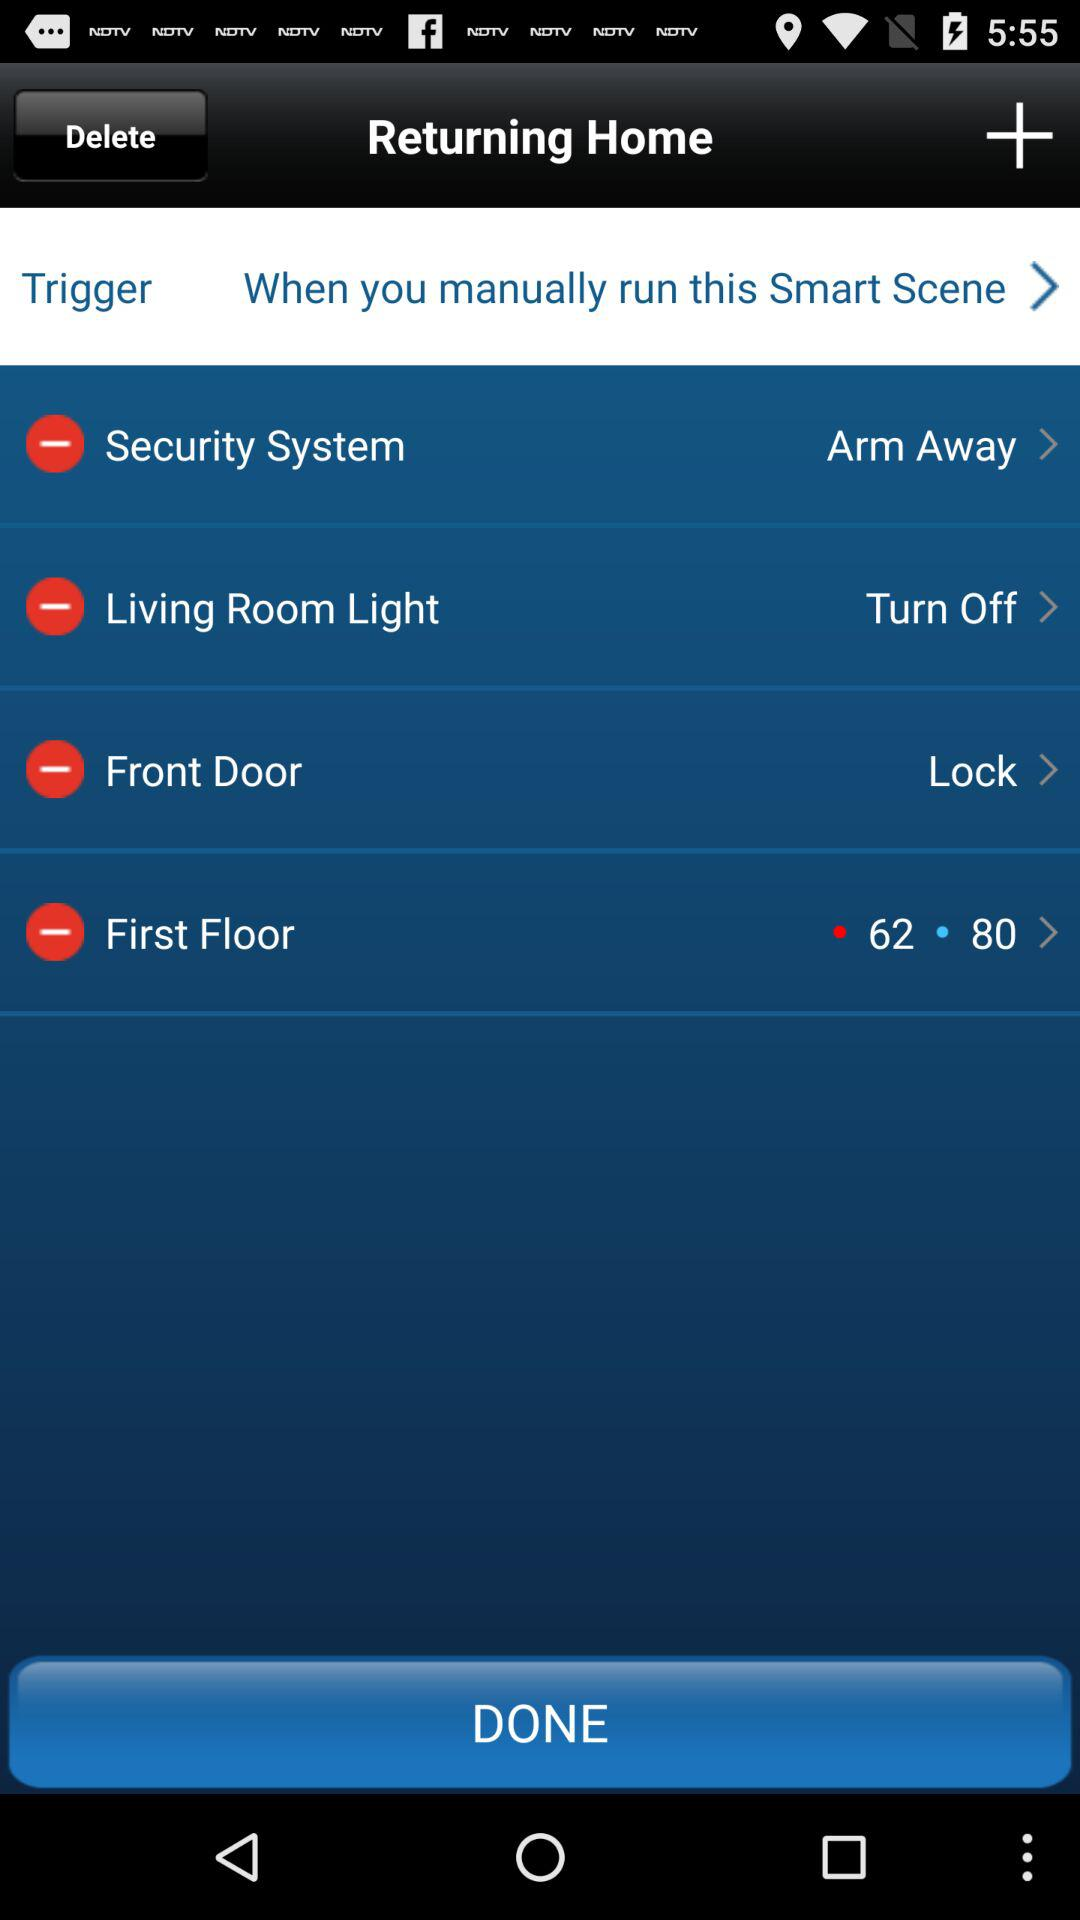What is the status of "Front Door"? The status of "Front Door" is "Lock". 